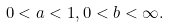Convert formula to latex. <formula><loc_0><loc_0><loc_500><loc_500>0 < a < 1 , 0 < b < \infty .</formula> 